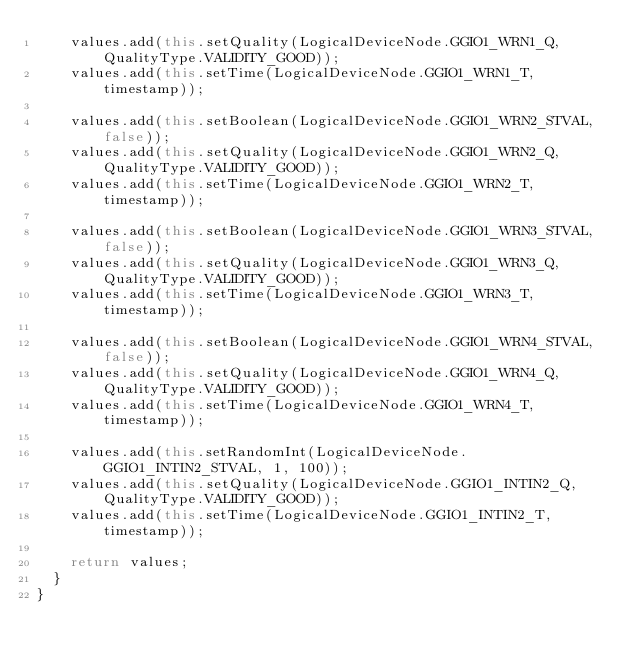Convert code to text. <code><loc_0><loc_0><loc_500><loc_500><_Java_>    values.add(this.setQuality(LogicalDeviceNode.GGIO1_WRN1_Q, QualityType.VALIDITY_GOOD));
    values.add(this.setTime(LogicalDeviceNode.GGIO1_WRN1_T, timestamp));

    values.add(this.setBoolean(LogicalDeviceNode.GGIO1_WRN2_STVAL, false));
    values.add(this.setQuality(LogicalDeviceNode.GGIO1_WRN2_Q, QualityType.VALIDITY_GOOD));
    values.add(this.setTime(LogicalDeviceNode.GGIO1_WRN2_T, timestamp));

    values.add(this.setBoolean(LogicalDeviceNode.GGIO1_WRN3_STVAL, false));
    values.add(this.setQuality(LogicalDeviceNode.GGIO1_WRN3_Q, QualityType.VALIDITY_GOOD));
    values.add(this.setTime(LogicalDeviceNode.GGIO1_WRN3_T, timestamp));

    values.add(this.setBoolean(LogicalDeviceNode.GGIO1_WRN4_STVAL, false));
    values.add(this.setQuality(LogicalDeviceNode.GGIO1_WRN4_Q, QualityType.VALIDITY_GOOD));
    values.add(this.setTime(LogicalDeviceNode.GGIO1_WRN4_T, timestamp));

    values.add(this.setRandomInt(LogicalDeviceNode.GGIO1_INTIN2_STVAL, 1, 100));
    values.add(this.setQuality(LogicalDeviceNode.GGIO1_INTIN2_Q, QualityType.VALIDITY_GOOD));
    values.add(this.setTime(LogicalDeviceNode.GGIO1_INTIN2_T, timestamp));

    return values;
  }
}
</code> 